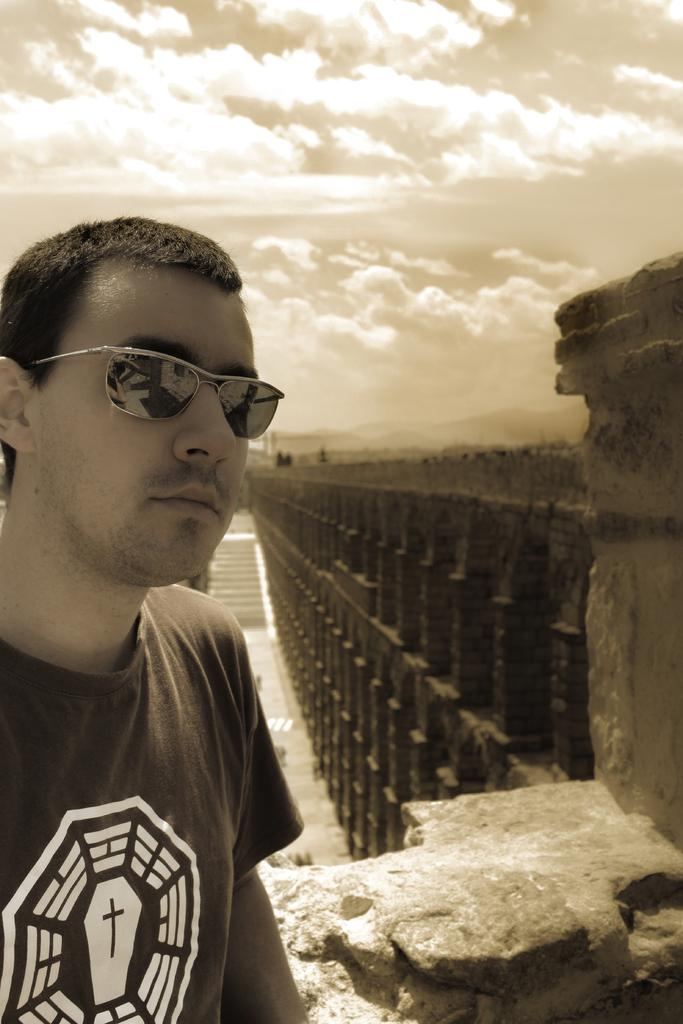Who or what is the main subject in the image? There is a person in the image. What is located behind the person? There are stairs behind the person. What is on the right side of the image? There is a wall on the right side of the image. What can be seen in the background of the image? There are clouds in the background of the image. How many ladybugs are crawling on the wall in the image? There are no ladybugs present in the image; only a person, stairs, and a wall are visible. What is the weight of the person in the image? The weight of the person in the image cannot be determined from the image alone. 